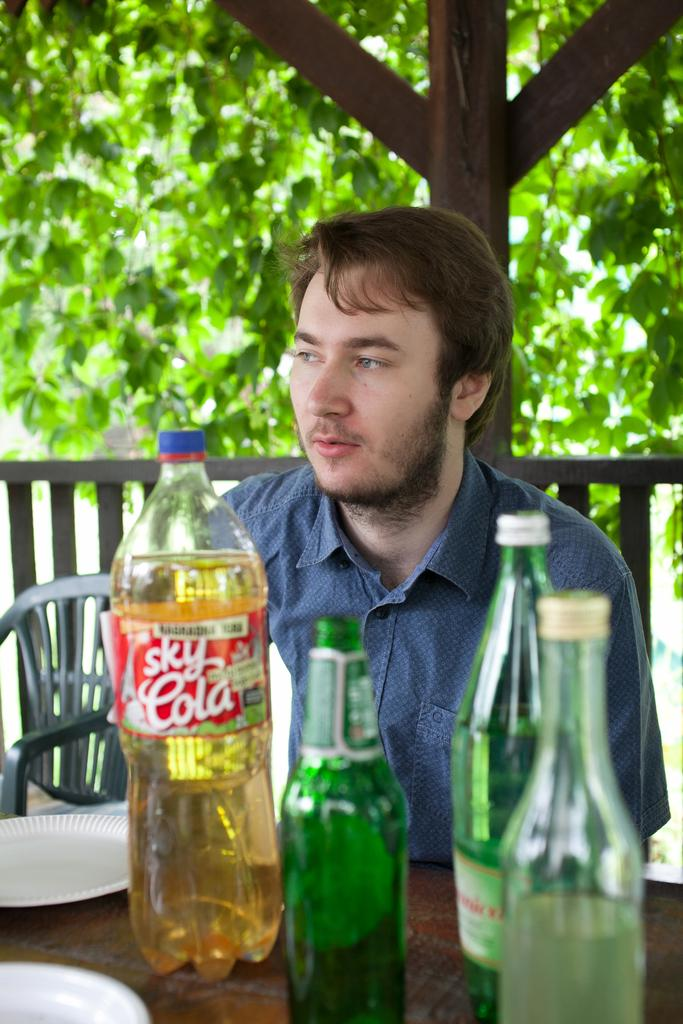<image>
Relay a brief, clear account of the picture shown. A man is sitting at a table behind an empty cola bottle. 